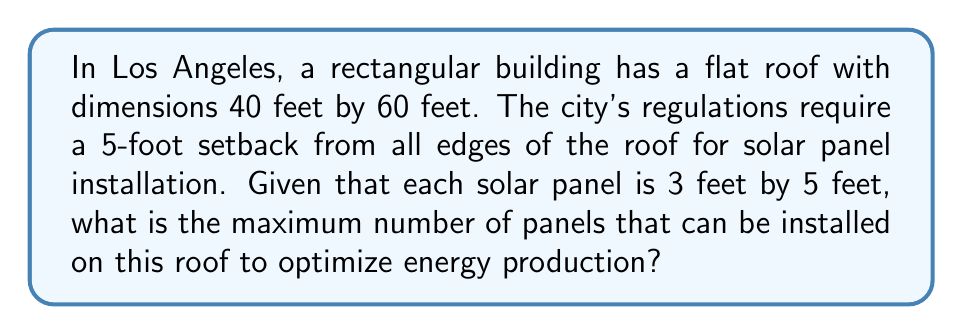Teach me how to tackle this problem. Let's approach this step-by-step:

1. First, we need to calculate the usable area of the roof after accounting for the setback:
   - Length of usable area: $60 - (2 \times 5) = 50$ feet
   - Width of usable area: $40 - (2 \times 5) = 30$ feet

2. The usable area is therefore:
   $A = 50 \times 30 = 1500$ square feet

3. Each solar panel has an area of:
   $A_{panel} = 3 \times 5 = 15$ square feet

4. To find the maximum number of panels, we divide the usable area by the area of each panel:
   $$N = \frac{A}{A_{panel}} = \frac{1500}{15} = 100$$

5. However, we need to consider that panels must be placed in whole numbers. We can verify if 100 panels fit exactly:
   - In the length: $50 \div 5 = 10$ panels
   - In the width: $30 \div 3 = 10$ panels
   
   Indeed, $10 \times 10 = 100$ panels fit perfectly.

Therefore, the maximum number of panels that can be installed is 100.
Answer: 100 panels 